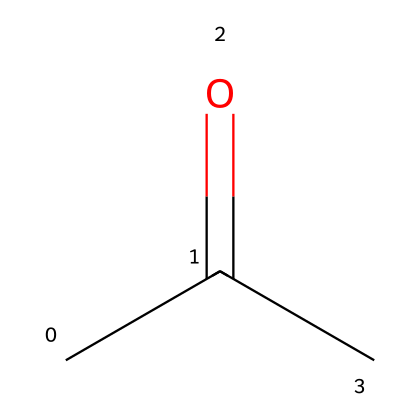What is the molecular formula of acetone? The SMILES representation CC(=O)C indicates that acetone contains three carbon atoms (C), six hydrogen atoms (H), and one oxygen atom (O). The molecular formula can be derived by counting the atoms represented in the structure.
Answer: C3H6O How many carbon atoms are present in the structure? By examining the SMILES notation CC(=O)C, we can see three 'C' characters which indicate there are three carbon atoms in total.
Answer: 3 What type of functional group is present in acetone? The molecule contains a carbonyl group indicated by the notation '(=O)', which signifies that the compound is a ketone due to the presence of carbonyl (C=O) between two carbon atoms.
Answer: ketone What is the hybridization of the carbonyl carbon in acetone? The carbonyl carbon in acetone is bonded to one carbon atom and one oxygen atom, with one double bond to oxygen and two single bonds to carbon atoms, indicating that it is sp2 hybridized.
Answer: sp2 How many hydrogen atoms are bound to the terminal carbon atoms of acetone? The structure shows that each terminal carbon atom is bonded to three hydrogen atoms, resulting in a total of six hydrogen atoms for the two terminal carbon atoms combined.
Answer: 6 What characteristic property of acetone makes it a good solvent? Acetone has a polar structure, which allows it to dissolve both polar and nonpolar substances effectively, making it a versatile solvent in many applications including use in nail polish remover.
Answer: polarity 